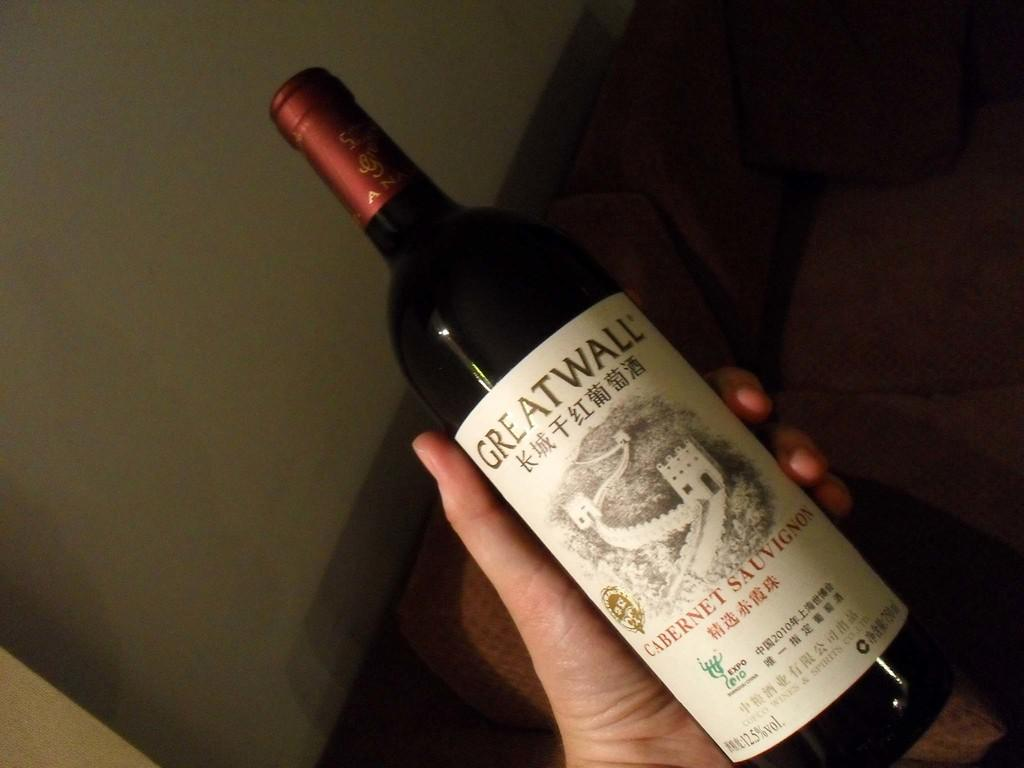<image>
Relay a brief, clear account of the picture shown. A person holds a bottle of cabernet in their left hand. 